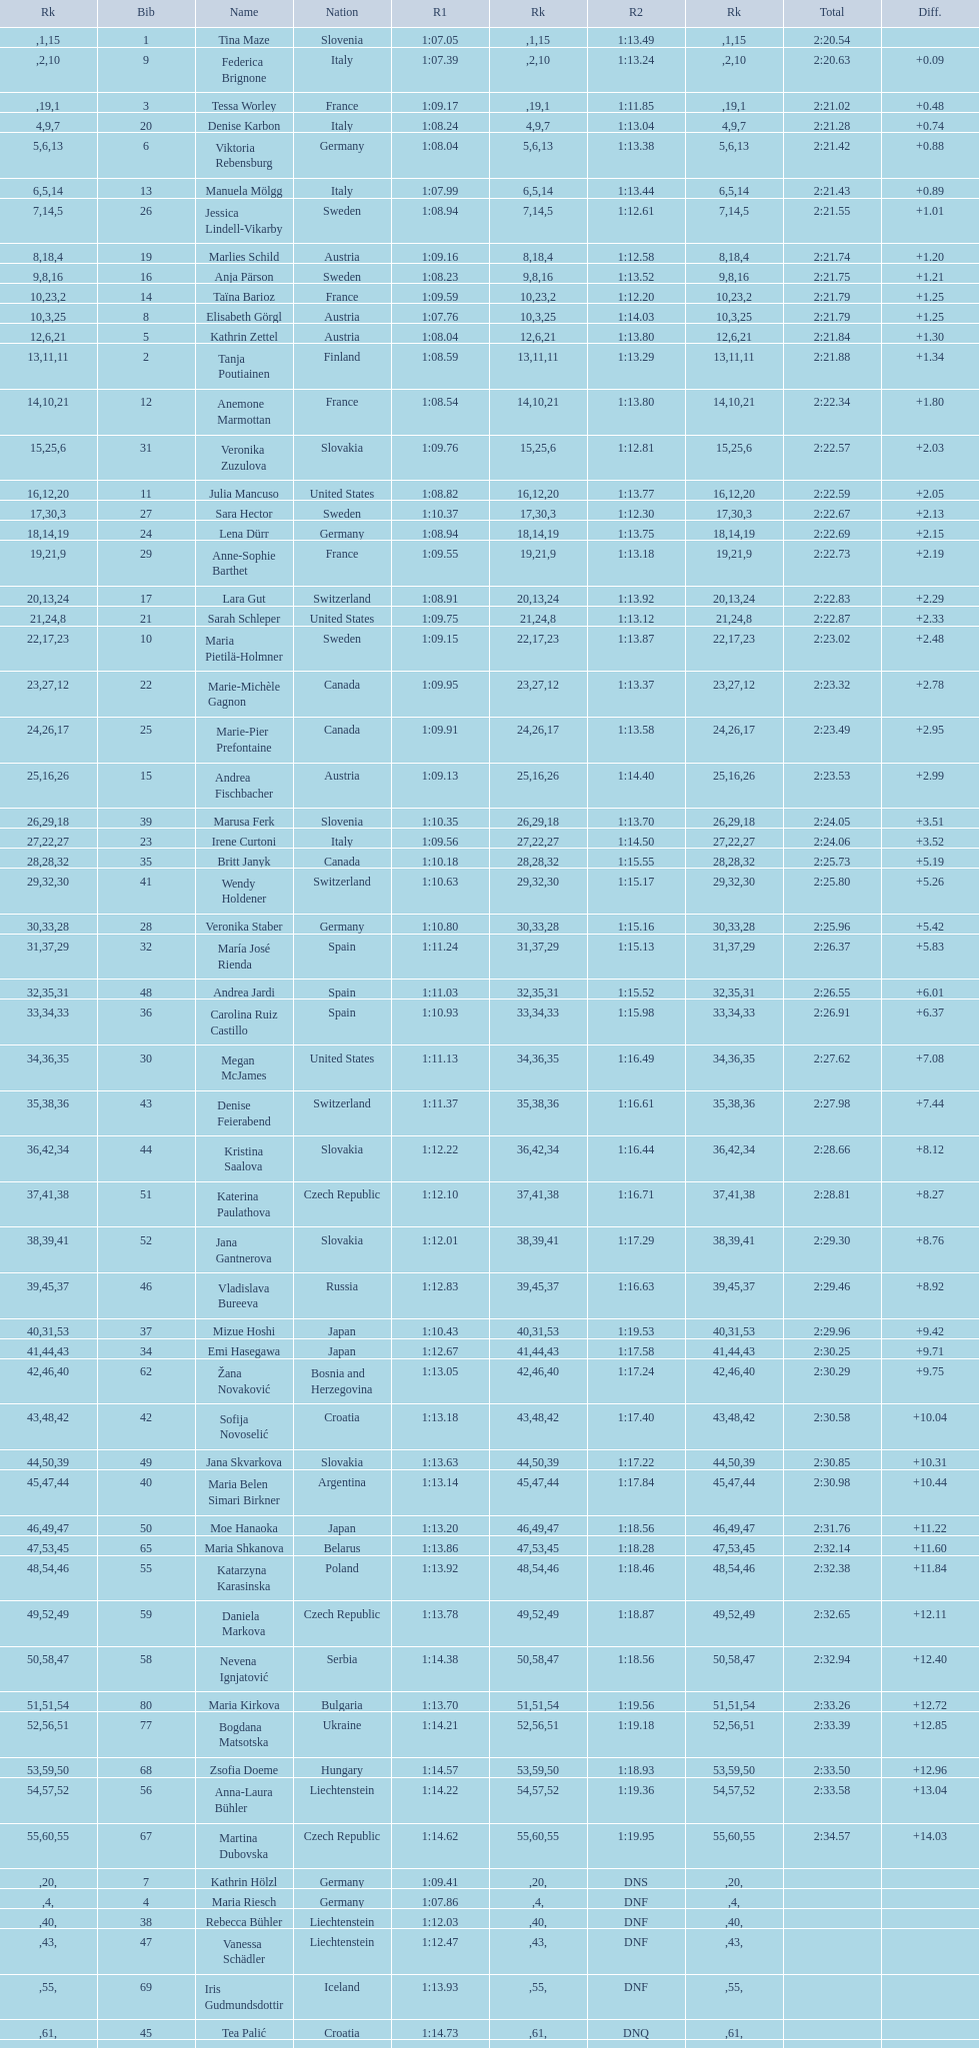How many italians finished in the top ten? 3. 